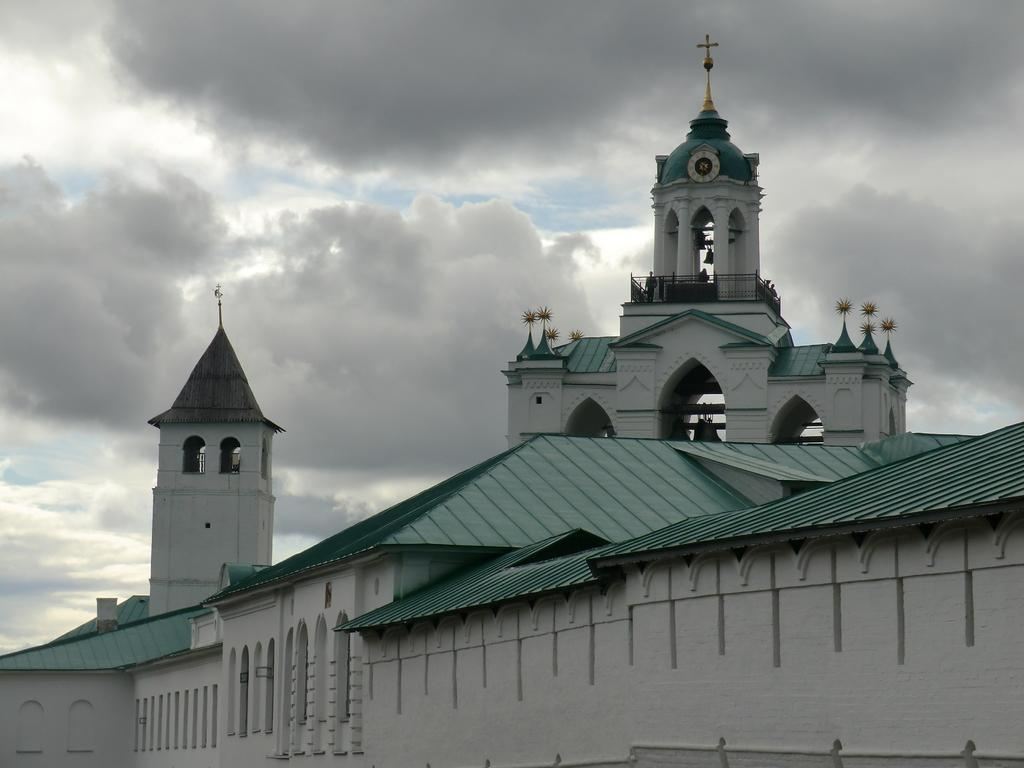What structure is the main subject of the image? There is a building in the image. What feature can be seen on the tower of the building? There is a clock on the tower wall of the building. What symbol is present on the tower? There is a cross symbol on the tower. What are the people in the image doing? There are people standing at the fence. What can be seen in the sky in the image? There are clouds in the sky. What type of creature is holding the string attached to the clock tower in the image? There is no creature holding a string attached to the clock tower in the image. 